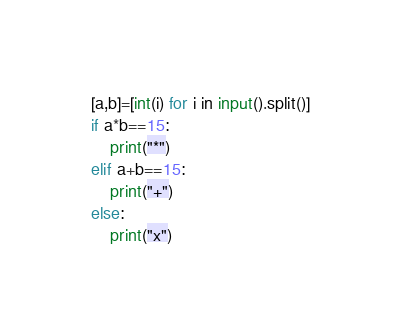<code> <loc_0><loc_0><loc_500><loc_500><_Python_>[a,b]=[int(i) for i in input().split()]
if a*b==15:
    print("*")
elif a+b==15:
    print("+")
else:
    print("x")
</code> 